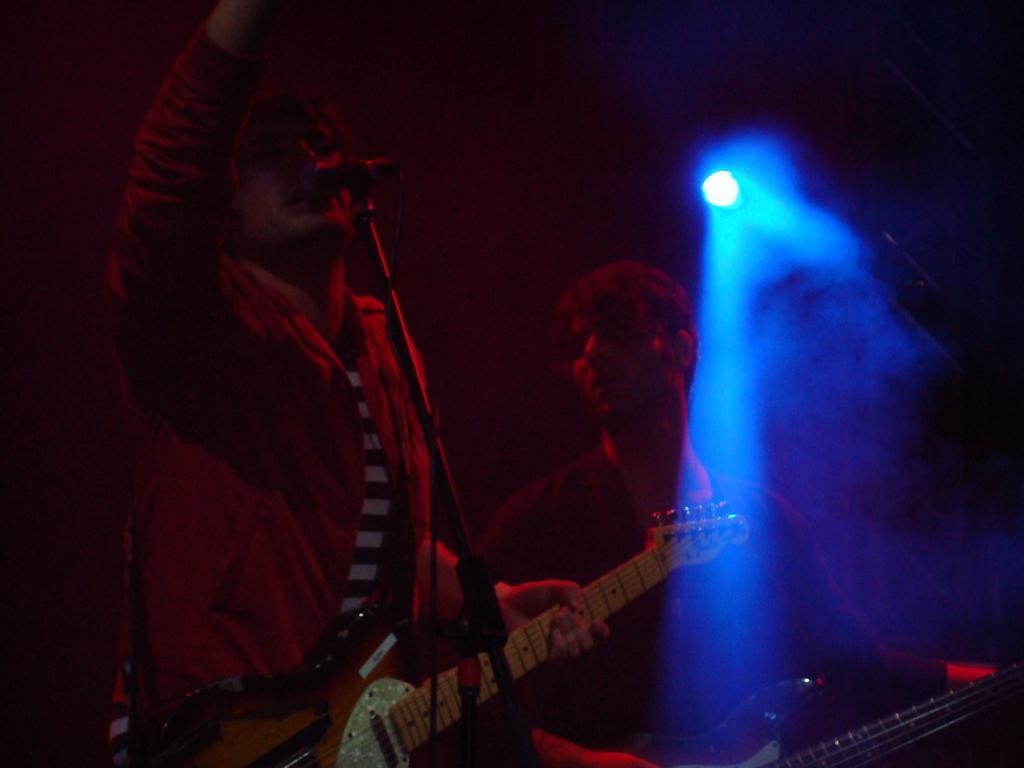Please provide a concise description of this image. There is a person standing on the left side. He is holding a guitar in his hand and he is singing on a microphone. There is another person on the right side and he is playing a guitar. Here we can see a lighting arrangement. 